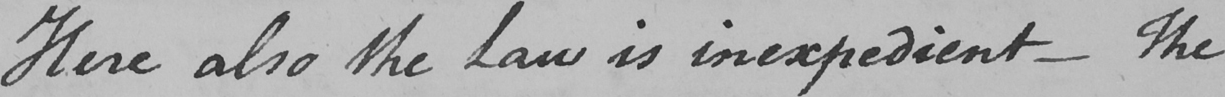Transcribe the text shown in this historical manuscript line. Here also the Law is inexpedient  _  The 